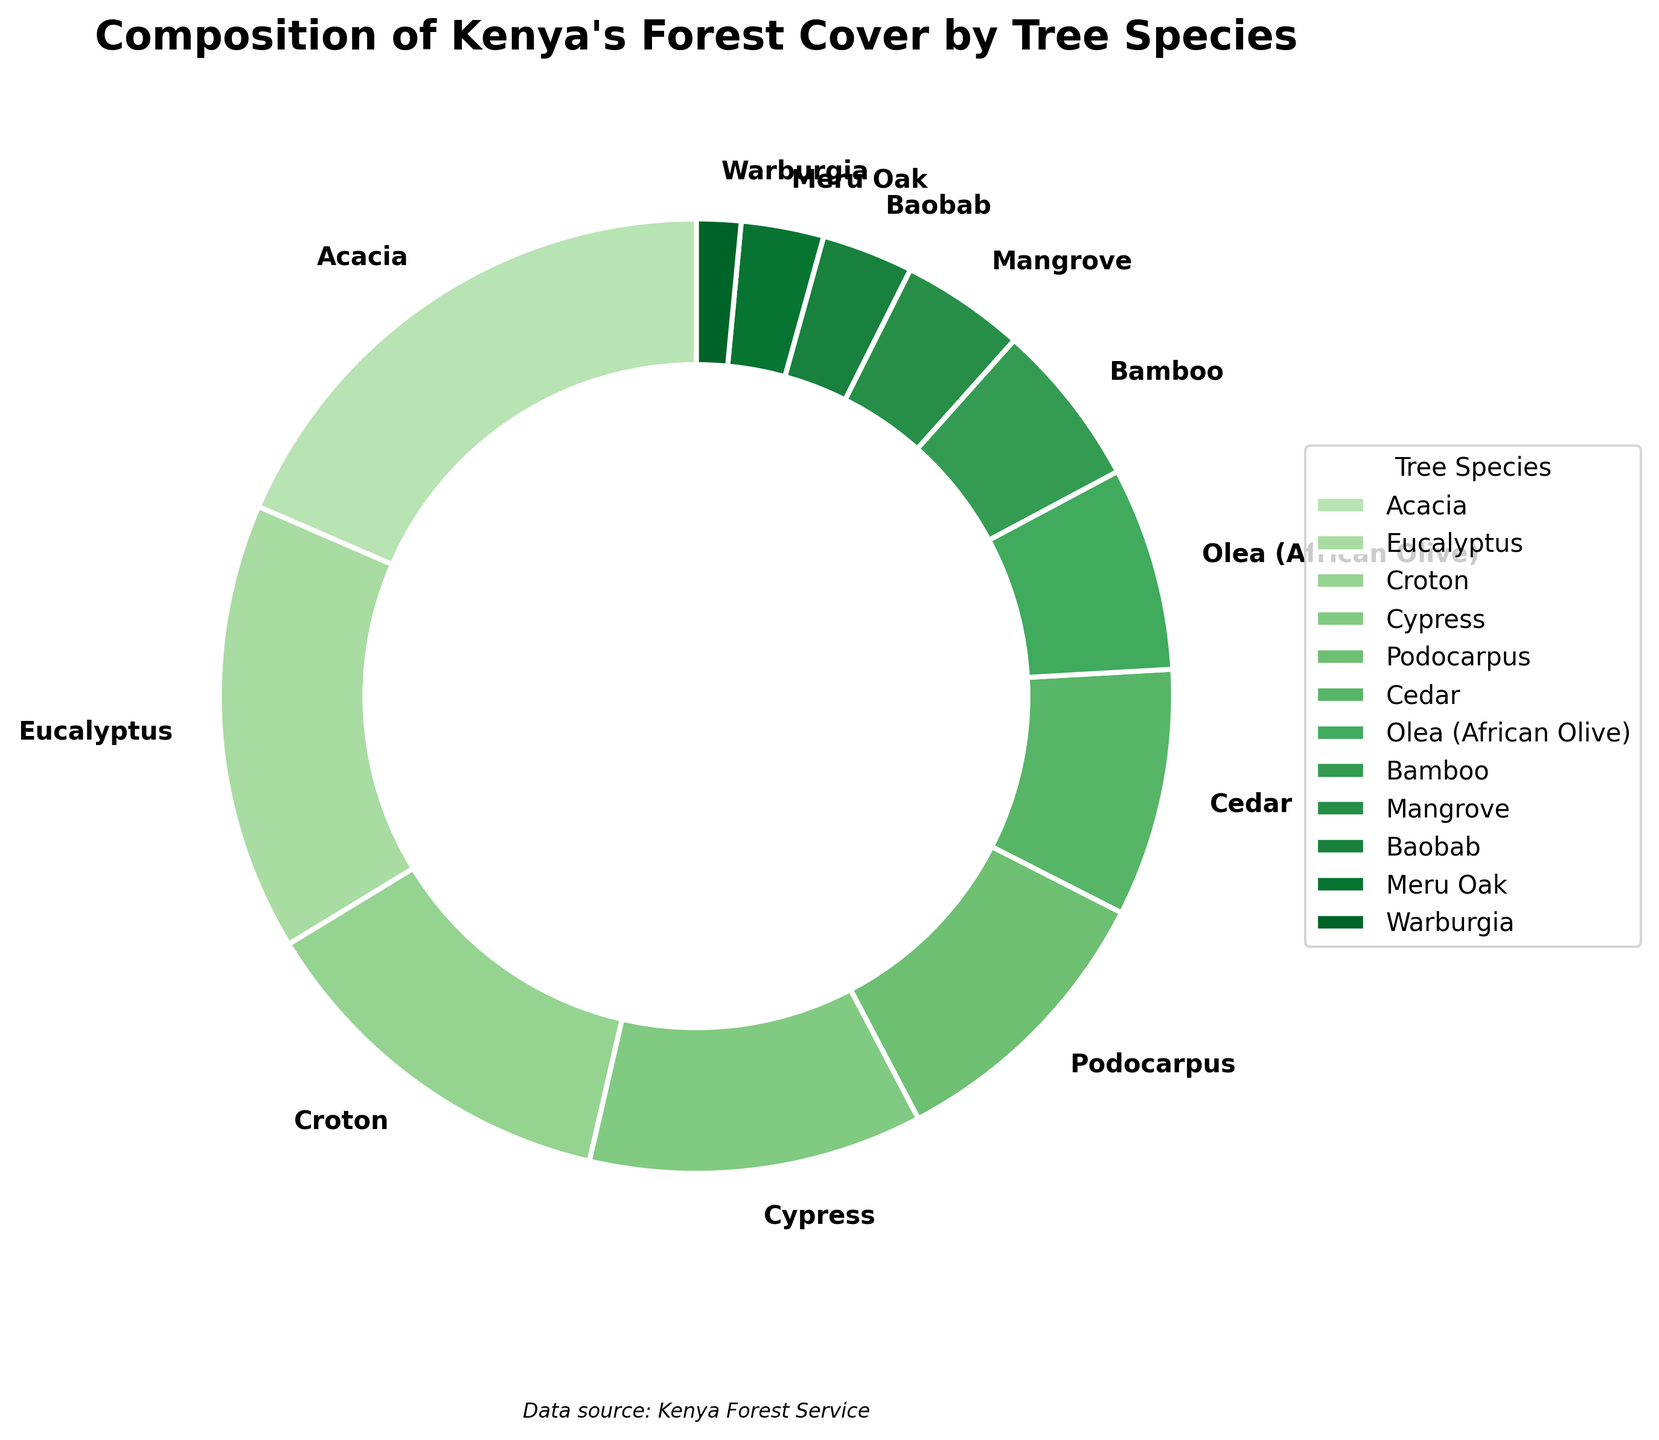What is the tree species with the highest percentage in Kenya's forest cover? To find the tree species with the highest percentage, look for the largest segment of the pie chart. Acacia is the species with the highest percentage at 18.5%.
Answer: Acacia Which tree species has the smallest percentage in Kenya's forest cover? Identify the smallest segment of the pie chart. Warburgia is the species with the smallest percentage at 1.5%.
Answer: Warburgia What is the combined percentage of the three most common tree species in Kenya's forest cover? Sum the percentages of the top three species: Acacia (18.5%), Eucalyptus (15.2%), Croton (12.7%). The total is 18.5 + 15.2 + 12.7 = 46.4%.
Answer: 46.4% Which tree species' segments are visually similar in size indicating close percentages? Compare the size of the segments. Cypress (11.3%) and Podocarpus (9.8%) have visually similar segment sizes on the pie chart, indicating close percentages.
Answer: Cypress and Podocarpus How does the percentage of Bamboo compare to that of Cedar in Kenya's forest cover? Look at the pie chart to compare the segments for Bamboo and Cedar. Bamboo has a smaller segment at 5.6% compared to Cedar’s segment at 8.4%.
Answer: Cedar has a higher percentage What is the difference in forest cover percentage between the species with the highest and lowest coverage? Subtract the lowest percentage (Warburgia, 1.5%) from the highest (Acacia, 18.5%): 18.5 - 1.5 = 17.
Answer: 17% If you combine the percentages of Baobab and Mangrove, is the total greater than the percentage of Eucalyptus? Sum the percentages of Baobab (3.1%) and Mangrove (4.2%): 3.1 + 4.2 = 7.3%. Compare this with Eucalyptus (15.2%). 7.3% is less than 15.2%.
Answer: No What is the total percentage of tree species in Kenya’s forest cover that individually account for less than 5% each? Identify species with less than 5%: Mangrove (4.2%), Baobab (3.1%), Meru Oak (2.8%), Warburgia (1.5%). Sum: 4.2 + 3.1 + 2.8 + 1.5 = 11.6%.
Answer: 11.6% Which tree species has a percentage closest to 10%? Find the segment nearest to 10%. Podocarpus is the closest with 9.8%.
Answer: Podocarpus 